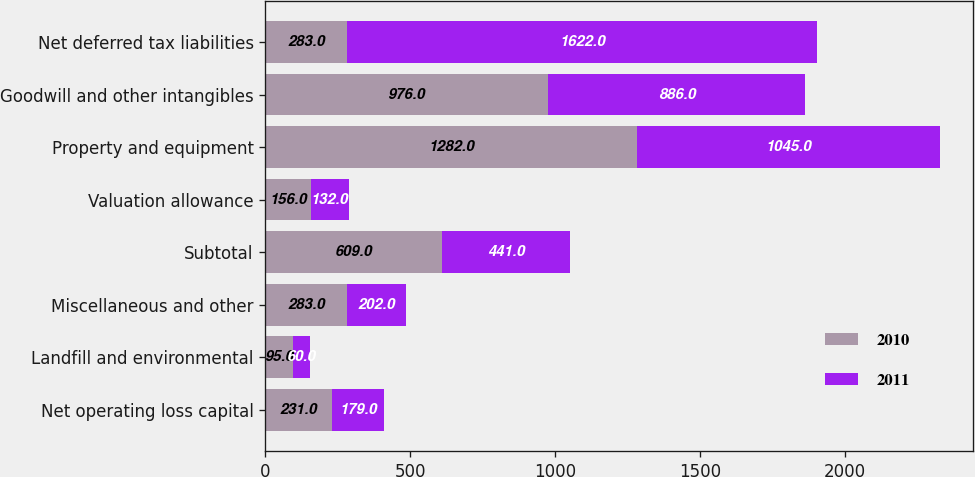<chart> <loc_0><loc_0><loc_500><loc_500><stacked_bar_chart><ecel><fcel>Net operating loss capital<fcel>Landfill and environmental<fcel>Miscellaneous and other<fcel>Subtotal<fcel>Valuation allowance<fcel>Property and equipment<fcel>Goodwill and other intangibles<fcel>Net deferred tax liabilities<nl><fcel>2010<fcel>231<fcel>95<fcel>283<fcel>609<fcel>156<fcel>1282<fcel>976<fcel>283<nl><fcel>2011<fcel>179<fcel>60<fcel>202<fcel>441<fcel>132<fcel>1045<fcel>886<fcel>1622<nl></chart> 